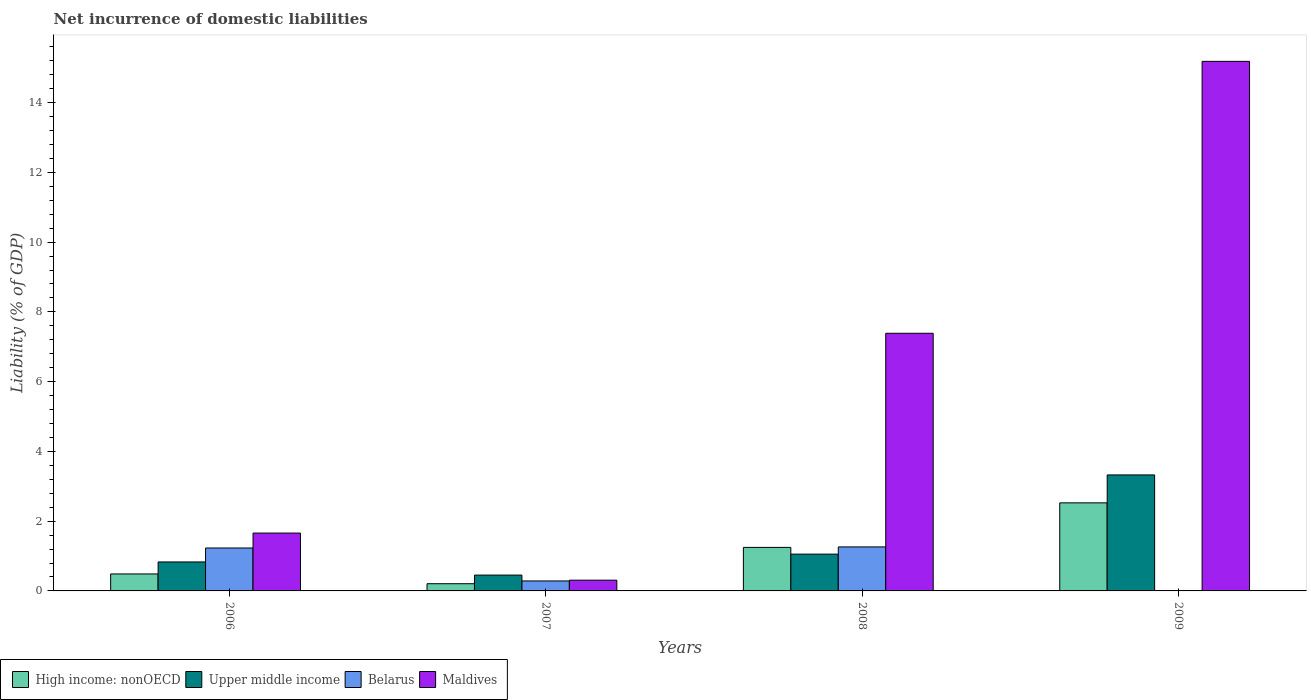How many different coloured bars are there?
Provide a short and direct response. 4. Are the number of bars per tick equal to the number of legend labels?
Ensure brevity in your answer.  No. How many bars are there on the 1st tick from the left?
Provide a short and direct response. 4. How many bars are there on the 4th tick from the right?
Offer a very short reply. 4. What is the label of the 2nd group of bars from the left?
Keep it short and to the point. 2007. In how many cases, is the number of bars for a given year not equal to the number of legend labels?
Provide a short and direct response. 1. What is the net incurrence of domestic liabilities in Upper middle income in 2006?
Your answer should be compact. 0.83. Across all years, what is the maximum net incurrence of domestic liabilities in Maldives?
Provide a short and direct response. 15.18. Across all years, what is the minimum net incurrence of domestic liabilities in High income: nonOECD?
Ensure brevity in your answer.  0.21. What is the total net incurrence of domestic liabilities in Maldives in the graph?
Your response must be concise. 24.53. What is the difference between the net incurrence of domestic liabilities in Maldives in 2008 and that in 2009?
Offer a very short reply. -7.8. What is the difference between the net incurrence of domestic liabilities in Upper middle income in 2008 and the net incurrence of domestic liabilities in Maldives in 2006?
Make the answer very short. -0.6. What is the average net incurrence of domestic liabilities in Maldives per year?
Provide a short and direct response. 6.13. In the year 2008, what is the difference between the net incurrence of domestic liabilities in Belarus and net incurrence of domestic liabilities in Upper middle income?
Ensure brevity in your answer.  0.21. What is the ratio of the net incurrence of domestic liabilities in Upper middle income in 2007 to that in 2008?
Offer a terse response. 0.43. Is the net incurrence of domestic liabilities in High income: nonOECD in 2008 less than that in 2009?
Make the answer very short. Yes. Is the difference between the net incurrence of domestic liabilities in Belarus in 2007 and 2008 greater than the difference between the net incurrence of domestic liabilities in Upper middle income in 2007 and 2008?
Offer a very short reply. No. What is the difference between the highest and the second highest net incurrence of domestic liabilities in High income: nonOECD?
Ensure brevity in your answer.  1.28. What is the difference between the highest and the lowest net incurrence of domestic liabilities in Maldives?
Your answer should be compact. 14.87. How many bars are there?
Ensure brevity in your answer.  15. Are all the bars in the graph horizontal?
Your response must be concise. No. How many years are there in the graph?
Offer a very short reply. 4. Are the values on the major ticks of Y-axis written in scientific E-notation?
Keep it short and to the point. No. Does the graph contain grids?
Make the answer very short. No. Where does the legend appear in the graph?
Offer a very short reply. Bottom left. How many legend labels are there?
Provide a short and direct response. 4. How are the legend labels stacked?
Provide a short and direct response. Horizontal. What is the title of the graph?
Give a very brief answer. Net incurrence of domestic liabilities. Does "Central Europe" appear as one of the legend labels in the graph?
Keep it short and to the point. No. What is the label or title of the Y-axis?
Keep it short and to the point. Liability (% of GDP). What is the Liability (% of GDP) of High income: nonOECD in 2006?
Make the answer very short. 0.49. What is the Liability (% of GDP) of Upper middle income in 2006?
Give a very brief answer. 0.83. What is the Liability (% of GDP) of Belarus in 2006?
Offer a very short reply. 1.23. What is the Liability (% of GDP) of Maldives in 2006?
Give a very brief answer. 1.66. What is the Liability (% of GDP) of High income: nonOECD in 2007?
Your response must be concise. 0.21. What is the Liability (% of GDP) of Upper middle income in 2007?
Your answer should be compact. 0.45. What is the Liability (% of GDP) of Belarus in 2007?
Offer a very short reply. 0.29. What is the Liability (% of GDP) in Maldives in 2007?
Make the answer very short. 0.31. What is the Liability (% of GDP) of High income: nonOECD in 2008?
Provide a short and direct response. 1.25. What is the Liability (% of GDP) of Upper middle income in 2008?
Your response must be concise. 1.05. What is the Liability (% of GDP) of Belarus in 2008?
Your answer should be very brief. 1.26. What is the Liability (% of GDP) of Maldives in 2008?
Your answer should be very brief. 7.39. What is the Liability (% of GDP) in High income: nonOECD in 2009?
Offer a terse response. 2.52. What is the Liability (% of GDP) in Upper middle income in 2009?
Offer a terse response. 3.33. What is the Liability (% of GDP) of Belarus in 2009?
Give a very brief answer. 0. What is the Liability (% of GDP) in Maldives in 2009?
Your answer should be compact. 15.18. Across all years, what is the maximum Liability (% of GDP) of High income: nonOECD?
Provide a short and direct response. 2.52. Across all years, what is the maximum Liability (% of GDP) of Upper middle income?
Provide a short and direct response. 3.33. Across all years, what is the maximum Liability (% of GDP) in Belarus?
Keep it short and to the point. 1.26. Across all years, what is the maximum Liability (% of GDP) of Maldives?
Give a very brief answer. 15.18. Across all years, what is the minimum Liability (% of GDP) of High income: nonOECD?
Your response must be concise. 0.21. Across all years, what is the minimum Liability (% of GDP) in Upper middle income?
Your answer should be very brief. 0.45. Across all years, what is the minimum Liability (% of GDP) in Maldives?
Give a very brief answer. 0.31. What is the total Liability (% of GDP) in High income: nonOECD in the graph?
Provide a short and direct response. 4.47. What is the total Liability (% of GDP) of Upper middle income in the graph?
Your answer should be very brief. 5.66. What is the total Liability (% of GDP) in Belarus in the graph?
Your answer should be very brief. 2.78. What is the total Liability (% of GDP) of Maldives in the graph?
Offer a terse response. 24.54. What is the difference between the Liability (% of GDP) of High income: nonOECD in 2006 and that in 2007?
Make the answer very short. 0.28. What is the difference between the Liability (% of GDP) of Upper middle income in 2006 and that in 2007?
Make the answer very short. 0.38. What is the difference between the Liability (% of GDP) of Belarus in 2006 and that in 2007?
Provide a short and direct response. 0.94. What is the difference between the Liability (% of GDP) in Maldives in 2006 and that in 2007?
Offer a very short reply. 1.35. What is the difference between the Liability (% of GDP) of High income: nonOECD in 2006 and that in 2008?
Keep it short and to the point. -0.76. What is the difference between the Liability (% of GDP) in Upper middle income in 2006 and that in 2008?
Your answer should be very brief. -0.22. What is the difference between the Liability (% of GDP) in Belarus in 2006 and that in 2008?
Give a very brief answer. -0.03. What is the difference between the Liability (% of GDP) in Maldives in 2006 and that in 2008?
Your response must be concise. -5.73. What is the difference between the Liability (% of GDP) in High income: nonOECD in 2006 and that in 2009?
Provide a short and direct response. -2.04. What is the difference between the Liability (% of GDP) in Upper middle income in 2006 and that in 2009?
Your answer should be compact. -2.49. What is the difference between the Liability (% of GDP) of Maldives in 2006 and that in 2009?
Give a very brief answer. -13.52. What is the difference between the Liability (% of GDP) in High income: nonOECD in 2007 and that in 2008?
Your answer should be compact. -1.04. What is the difference between the Liability (% of GDP) of Upper middle income in 2007 and that in 2008?
Your response must be concise. -0.6. What is the difference between the Liability (% of GDP) in Belarus in 2007 and that in 2008?
Provide a succinct answer. -0.98. What is the difference between the Liability (% of GDP) of Maldives in 2007 and that in 2008?
Provide a short and direct response. -7.08. What is the difference between the Liability (% of GDP) in High income: nonOECD in 2007 and that in 2009?
Give a very brief answer. -2.32. What is the difference between the Liability (% of GDP) of Upper middle income in 2007 and that in 2009?
Ensure brevity in your answer.  -2.87. What is the difference between the Liability (% of GDP) of Maldives in 2007 and that in 2009?
Your response must be concise. -14.87. What is the difference between the Liability (% of GDP) of High income: nonOECD in 2008 and that in 2009?
Your answer should be compact. -1.28. What is the difference between the Liability (% of GDP) in Upper middle income in 2008 and that in 2009?
Your answer should be compact. -2.27. What is the difference between the Liability (% of GDP) of Maldives in 2008 and that in 2009?
Ensure brevity in your answer.  -7.8. What is the difference between the Liability (% of GDP) in High income: nonOECD in 2006 and the Liability (% of GDP) in Upper middle income in 2007?
Give a very brief answer. 0.03. What is the difference between the Liability (% of GDP) in High income: nonOECD in 2006 and the Liability (% of GDP) in Belarus in 2007?
Offer a terse response. 0.2. What is the difference between the Liability (% of GDP) of High income: nonOECD in 2006 and the Liability (% of GDP) of Maldives in 2007?
Your response must be concise. 0.18. What is the difference between the Liability (% of GDP) of Upper middle income in 2006 and the Liability (% of GDP) of Belarus in 2007?
Offer a terse response. 0.54. What is the difference between the Liability (% of GDP) of Upper middle income in 2006 and the Liability (% of GDP) of Maldives in 2007?
Offer a terse response. 0.52. What is the difference between the Liability (% of GDP) in Belarus in 2006 and the Liability (% of GDP) in Maldives in 2007?
Ensure brevity in your answer.  0.92. What is the difference between the Liability (% of GDP) of High income: nonOECD in 2006 and the Liability (% of GDP) of Upper middle income in 2008?
Ensure brevity in your answer.  -0.57. What is the difference between the Liability (% of GDP) of High income: nonOECD in 2006 and the Liability (% of GDP) of Belarus in 2008?
Your answer should be compact. -0.77. What is the difference between the Liability (% of GDP) in High income: nonOECD in 2006 and the Liability (% of GDP) in Maldives in 2008?
Make the answer very short. -6.9. What is the difference between the Liability (% of GDP) in Upper middle income in 2006 and the Liability (% of GDP) in Belarus in 2008?
Give a very brief answer. -0.43. What is the difference between the Liability (% of GDP) of Upper middle income in 2006 and the Liability (% of GDP) of Maldives in 2008?
Provide a short and direct response. -6.56. What is the difference between the Liability (% of GDP) of Belarus in 2006 and the Liability (% of GDP) of Maldives in 2008?
Provide a succinct answer. -6.16. What is the difference between the Liability (% of GDP) in High income: nonOECD in 2006 and the Liability (% of GDP) in Upper middle income in 2009?
Your answer should be compact. -2.84. What is the difference between the Liability (% of GDP) in High income: nonOECD in 2006 and the Liability (% of GDP) in Maldives in 2009?
Your answer should be compact. -14.7. What is the difference between the Liability (% of GDP) in Upper middle income in 2006 and the Liability (% of GDP) in Maldives in 2009?
Your answer should be very brief. -14.35. What is the difference between the Liability (% of GDP) of Belarus in 2006 and the Liability (% of GDP) of Maldives in 2009?
Ensure brevity in your answer.  -13.95. What is the difference between the Liability (% of GDP) in High income: nonOECD in 2007 and the Liability (% of GDP) in Upper middle income in 2008?
Offer a terse response. -0.85. What is the difference between the Liability (% of GDP) of High income: nonOECD in 2007 and the Liability (% of GDP) of Belarus in 2008?
Offer a terse response. -1.06. What is the difference between the Liability (% of GDP) of High income: nonOECD in 2007 and the Liability (% of GDP) of Maldives in 2008?
Give a very brief answer. -7.18. What is the difference between the Liability (% of GDP) of Upper middle income in 2007 and the Liability (% of GDP) of Belarus in 2008?
Offer a terse response. -0.81. What is the difference between the Liability (% of GDP) of Upper middle income in 2007 and the Liability (% of GDP) of Maldives in 2008?
Your response must be concise. -6.93. What is the difference between the Liability (% of GDP) in Belarus in 2007 and the Liability (% of GDP) in Maldives in 2008?
Ensure brevity in your answer.  -7.1. What is the difference between the Liability (% of GDP) of High income: nonOECD in 2007 and the Liability (% of GDP) of Upper middle income in 2009?
Your answer should be very brief. -3.12. What is the difference between the Liability (% of GDP) of High income: nonOECD in 2007 and the Liability (% of GDP) of Maldives in 2009?
Offer a very short reply. -14.98. What is the difference between the Liability (% of GDP) of Upper middle income in 2007 and the Liability (% of GDP) of Maldives in 2009?
Keep it short and to the point. -14.73. What is the difference between the Liability (% of GDP) of Belarus in 2007 and the Liability (% of GDP) of Maldives in 2009?
Keep it short and to the point. -14.9. What is the difference between the Liability (% of GDP) in High income: nonOECD in 2008 and the Liability (% of GDP) in Upper middle income in 2009?
Offer a terse response. -2.08. What is the difference between the Liability (% of GDP) of High income: nonOECD in 2008 and the Liability (% of GDP) of Maldives in 2009?
Offer a terse response. -13.93. What is the difference between the Liability (% of GDP) in Upper middle income in 2008 and the Liability (% of GDP) in Maldives in 2009?
Your answer should be compact. -14.13. What is the difference between the Liability (% of GDP) in Belarus in 2008 and the Liability (% of GDP) in Maldives in 2009?
Give a very brief answer. -13.92. What is the average Liability (% of GDP) in High income: nonOECD per year?
Provide a short and direct response. 1.12. What is the average Liability (% of GDP) of Upper middle income per year?
Keep it short and to the point. 1.42. What is the average Liability (% of GDP) in Belarus per year?
Make the answer very short. 0.69. What is the average Liability (% of GDP) in Maldives per year?
Offer a terse response. 6.13. In the year 2006, what is the difference between the Liability (% of GDP) in High income: nonOECD and Liability (% of GDP) in Upper middle income?
Provide a succinct answer. -0.34. In the year 2006, what is the difference between the Liability (% of GDP) of High income: nonOECD and Liability (% of GDP) of Belarus?
Keep it short and to the point. -0.74. In the year 2006, what is the difference between the Liability (% of GDP) in High income: nonOECD and Liability (% of GDP) in Maldives?
Offer a terse response. -1.17. In the year 2006, what is the difference between the Liability (% of GDP) of Upper middle income and Liability (% of GDP) of Belarus?
Your answer should be very brief. -0.4. In the year 2006, what is the difference between the Liability (% of GDP) of Upper middle income and Liability (% of GDP) of Maldives?
Give a very brief answer. -0.83. In the year 2006, what is the difference between the Liability (% of GDP) of Belarus and Liability (% of GDP) of Maldives?
Provide a short and direct response. -0.43. In the year 2007, what is the difference between the Liability (% of GDP) of High income: nonOECD and Liability (% of GDP) of Upper middle income?
Provide a short and direct response. -0.25. In the year 2007, what is the difference between the Liability (% of GDP) of High income: nonOECD and Liability (% of GDP) of Belarus?
Make the answer very short. -0.08. In the year 2007, what is the difference between the Liability (% of GDP) of High income: nonOECD and Liability (% of GDP) of Maldives?
Provide a succinct answer. -0.1. In the year 2007, what is the difference between the Liability (% of GDP) of Upper middle income and Liability (% of GDP) of Belarus?
Offer a very short reply. 0.17. In the year 2007, what is the difference between the Liability (% of GDP) in Upper middle income and Liability (% of GDP) in Maldives?
Your answer should be compact. 0.15. In the year 2007, what is the difference between the Liability (% of GDP) in Belarus and Liability (% of GDP) in Maldives?
Provide a short and direct response. -0.02. In the year 2008, what is the difference between the Liability (% of GDP) of High income: nonOECD and Liability (% of GDP) of Upper middle income?
Give a very brief answer. 0.19. In the year 2008, what is the difference between the Liability (% of GDP) of High income: nonOECD and Liability (% of GDP) of Belarus?
Provide a succinct answer. -0.01. In the year 2008, what is the difference between the Liability (% of GDP) of High income: nonOECD and Liability (% of GDP) of Maldives?
Provide a succinct answer. -6.14. In the year 2008, what is the difference between the Liability (% of GDP) in Upper middle income and Liability (% of GDP) in Belarus?
Give a very brief answer. -0.21. In the year 2008, what is the difference between the Liability (% of GDP) of Upper middle income and Liability (% of GDP) of Maldives?
Provide a short and direct response. -6.33. In the year 2008, what is the difference between the Liability (% of GDP) of Belarus and Liability (% of GDP) of Maldives?
Offer a very short reply. -6.12. In the year 2009, what is the difference between the Liability (% of GDP) in High income: nonOECD and Liability (% of GDP) in Upper middle income?
Provide a succinct answer. -0.8. In the year 2009, what is the difference between the Liability (% of GDP) in High income: nonOECD and Liability (% of GDP) in Maldives?
Your answer should be very brief. -12.66. In the year 2009, what is the difference between the Liability (% of GDP) of Upper middle income and Liability (% of GDP) of Maldives?
Your answer should be very brief. -11.86. What is the ratio of the Liability (% of GDP) of High income: nonOECD in 2006 to that in 2007?
Offer a terse response. 2.36. What is the ratio of the Liability (% of GDP) in Upper middle income in 2006 to that in 2007?
Give a very brief answer. 1.83. What is the ratio of the Liability (% of GDP) in Belarus in 2006 to that in 2007?
Keep it short and to the point. 4.3. What is the ratio of the Liability (% of GDP) in Maldives in 2006 to that in 2007?
Provide a succinct answer. 5.39. What is the ratio of the Liability (% of GDP) in High income: nonOECD in 2006 to that in 2008?
Offer a terse response. 0.39. What is the ratio of the Liability (% of GDP) in Upper middle income in 2006 to that in 2008?
Keep it short and to the point. 0.79. What is the ratio of the Liability (% of GDP) in Belarus in 2006 to that in 2008?
Your response must be concise. 0.98. What is the ratio of the Liability (% of GDP) in Maldives in 2006 to that in 2008?
Keep it short and to the point. 0.22. What is the ratio of the Liability (% of GDP) in High income: nonOECD in 2006 to that in 2009?
Provide a succinct answer. 0.19. What is the ratio of the Liability (% of GDP) in Upper middle income in 2006 to that in 2009?
Offer a very short reply. 0.25. What is the ratio of the Liability (% of GDP) of Maldives in 2006 to that in 2009?
Keep it short and to the point. 0.11. What is the ratio of the Liability (% of GDP) in High income: nonOECD in 2007 to that in 2008?
Your answer should be very brief. 0.17. What is the ratio of the Liability (% of GDP) of Upper middle income in 2007 to that in 2008?
Provide a succinct answer. 0.43. What is the ratio of the Liability (% of GDP) in Belarus in 2007 to that in 2008?
Your answer should be compact. 0.23. What is the ratio of the Liability (% of GDP) of Maldives in 2007 to that in 2008?
Provide a succinct answer. 0.04. What is the ratio of the Liability (% of GDP) of High income: nonOECD in 2007 to that in 2009?
Ensure brevity in your answer.  0.08. What is the ratio of the Liability (% of GDP) in Upper middle income in 2007 to that in 2009?
Provide a succinct answer. 0.14. What is the ratio of the Liability (% of GDP) in Maldives in 2007 to that in 2009?
Keep it short and to the point. 0.02. What is the ratio of the Liability (% of GDP) in High income: nonOECD in 2008 to that in 2009?
Provide a succinct answer. 0.49. What is the ratio of the Liability (% of GDP) of Upper middle income in 2008 to that in 2009?
Provide a succinct answer. 0.32. What is the ratio of the Liability (% of GDP) of Maldives in 2008 to that in 2009?
Keep it short and to the point. 0.49. What is the difference between the highest and the second highest Liability (% of GDP) of High income: nonOECD?
Keep it short and to the point. 1.28. What is the difference between the highest and the second highest Liability (% of GDP) in Upper middle income?
Provide a short and direct response. 2.27. What is the difference between the highest and the second highest Liability (% of GDP) of Belarus?
Offer a very short reply. 0.03. What is the difference between the highest and the second highest Liability (% of GDP) in Maldives?
Your answer should be compact. 7.8. What is the difference between the highest and the lowest Liability (% of GDP) in High income: nonOECD?
Provide a succinct answer. 2.32. What is the difference between the highest and the lowest Liability (% of GDP) in Upper middle income?
Your answer should be compact. 2.87. What is the difference between the highest and the lowest Liability (% of GDP) of Belarus?
Keep it short and to the point. 1.26. What is the difference between the highest and the lowest Liability (% of GDP) in Maldives?
Your answer should be compact. 14.87. 